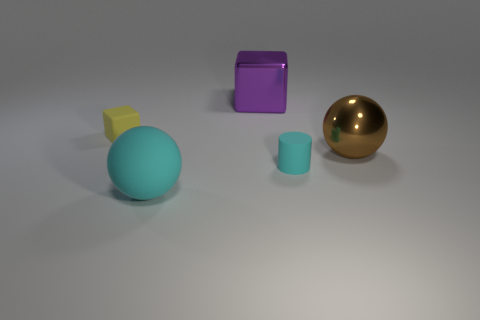Add 2 matte blocks. How many objects exist? 7 Subtract all balls. How many objects are left? 3 Subtract all big purple things. Subtract all large metallic objects. How many objects are left? 2 Add 5 blocks. How many blocks are left? 7 Add 5 cylinders. How many cylinders exist? 6 Subtract 0 green cubes. How many objects are left? 5 